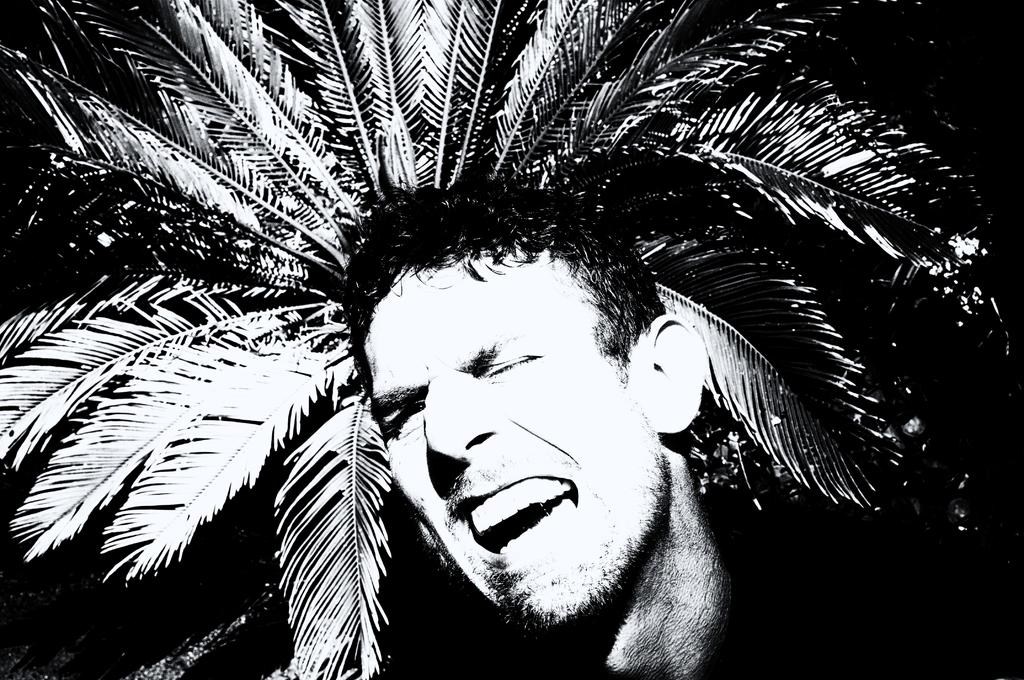Who is present in the image? There is a man in the image. What is the man wearing? The man is wearing a black jacket. What natural element can be seen in the image? There is a tree in the image. How would you describe the lighting in the image? The image is slightly dark. How does the man increase the size of the wound on his arm in the image? There is no wound present on the man's arm in the image. 